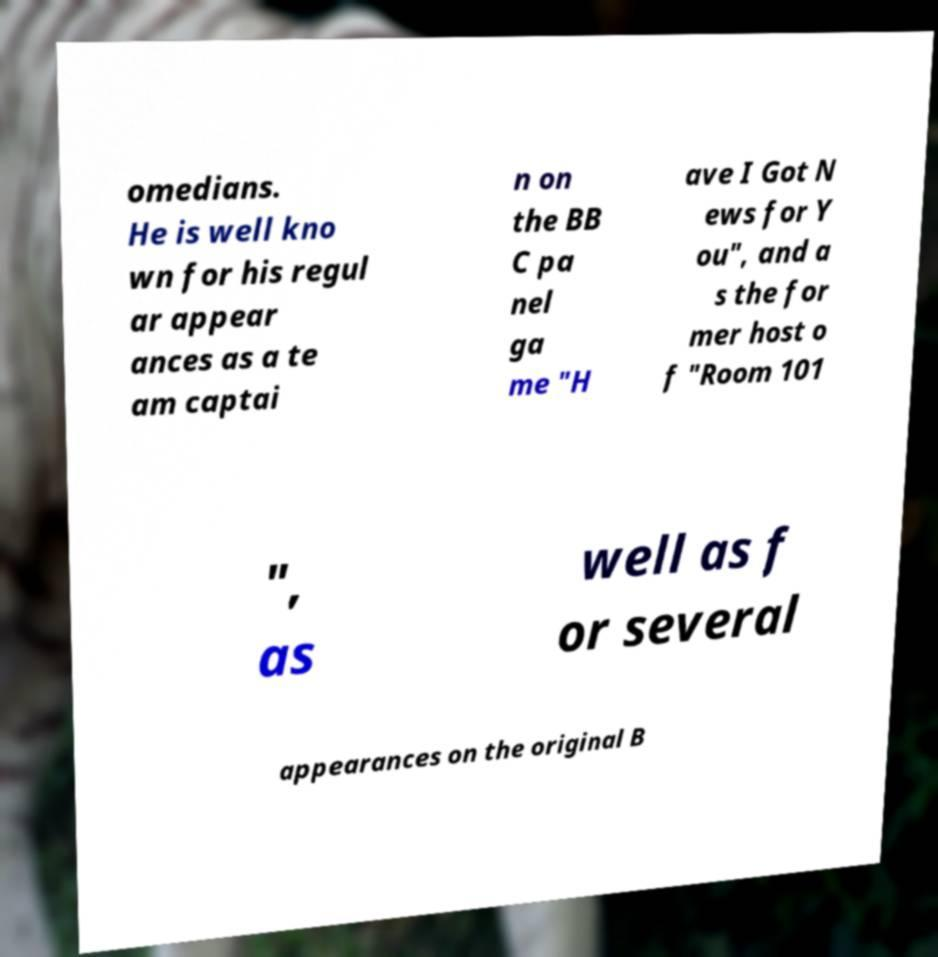I need the written content from this picture converted into text. Can you do that? omedians. He is well kno wn for his regul ar appear ances as a te am captai n on the BB C pa nel ga me "H ave I Got N ews for Y ou", and a s the for mer host o f "Room 101 ", as well as f or several appearances on the original B 